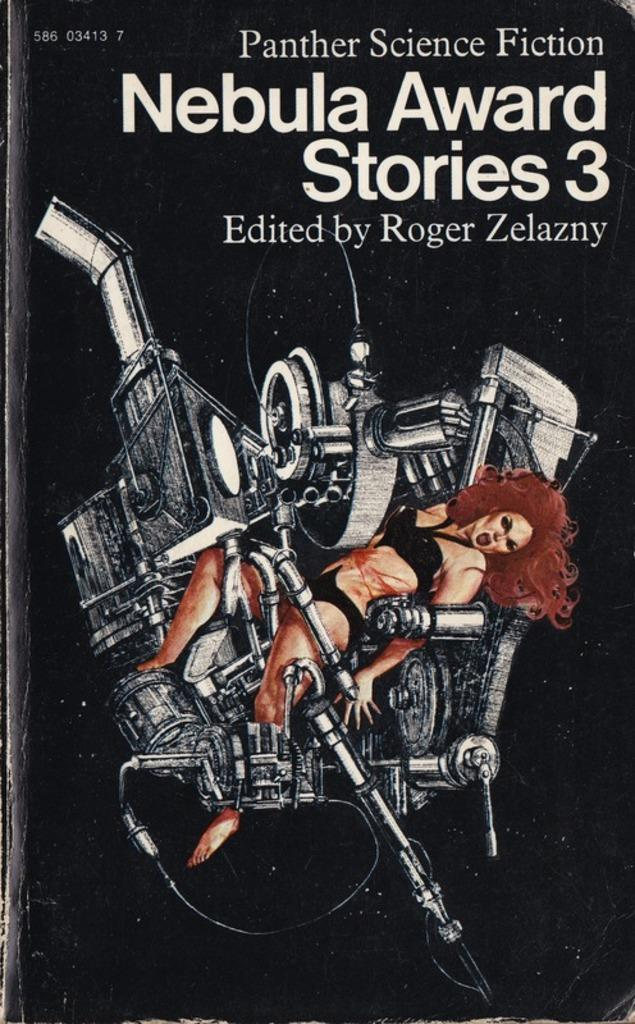Provide a one-sentence caption for the provided image. Third series of the Panther Science fiction Nebula Award Stories. 